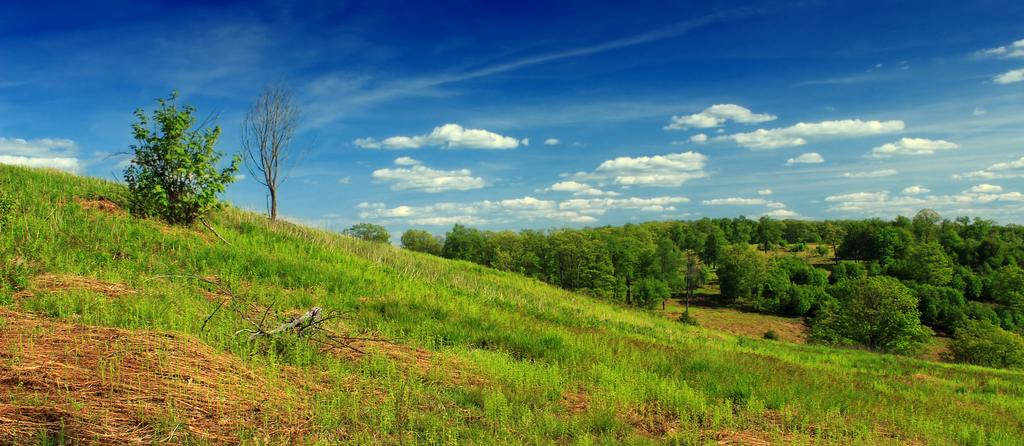What type of vegetation can be seen in the image? There is grass in the image. What is the color of the grass? The grass is green. What other natural elements are present in the image? There are trees in the image. What is the color of the trees? The trees are green. What can be seen in the background of the image? The sky is visible in the background of the image. What colors are present in the sky? The sky is blue and white. Can you compare the size of the boat to the trees in the image? There is no boat present in the image, so it is not possible to make a comparison. 